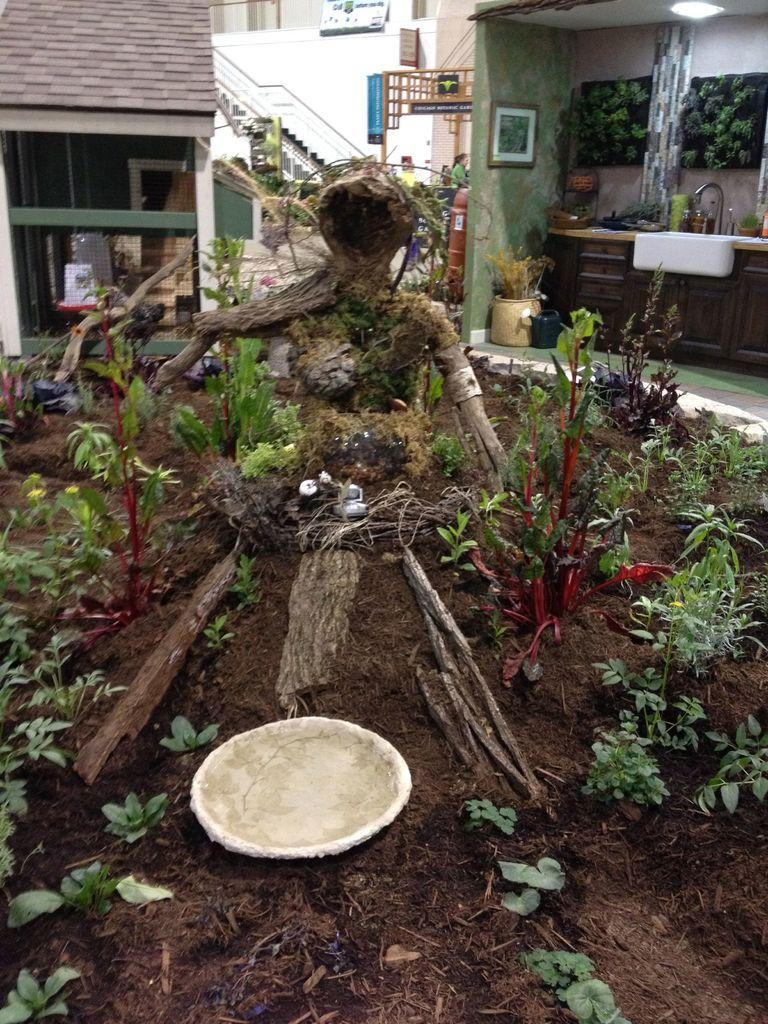What type of object is the main subject of the image? There is a wooden statue in the image. What other elements are present in the image besides the statue? There are plants in the image. What can be seen in the background of the image? The background of the image includes a kitchen, stairs, and a house. What type of seed is being planted in the image? There is no seed or planting activity depicted in the image; it features a wooden statue and plants. What message of peace is being conveyed in the image? There is no message of peace or any text present in the image; it only contains a wooden statue, plants, and a background with a kitchen, stairs, and a house. 